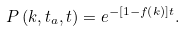Convert formula to latex. <formula><loc_0><loc_0><loc_500><loc_500>P \left ( { k } , t _ { a } , t \right ) = e ^ { - \left [ 1 - f \left ( { k } \right ) \right ] t } .</formula> 